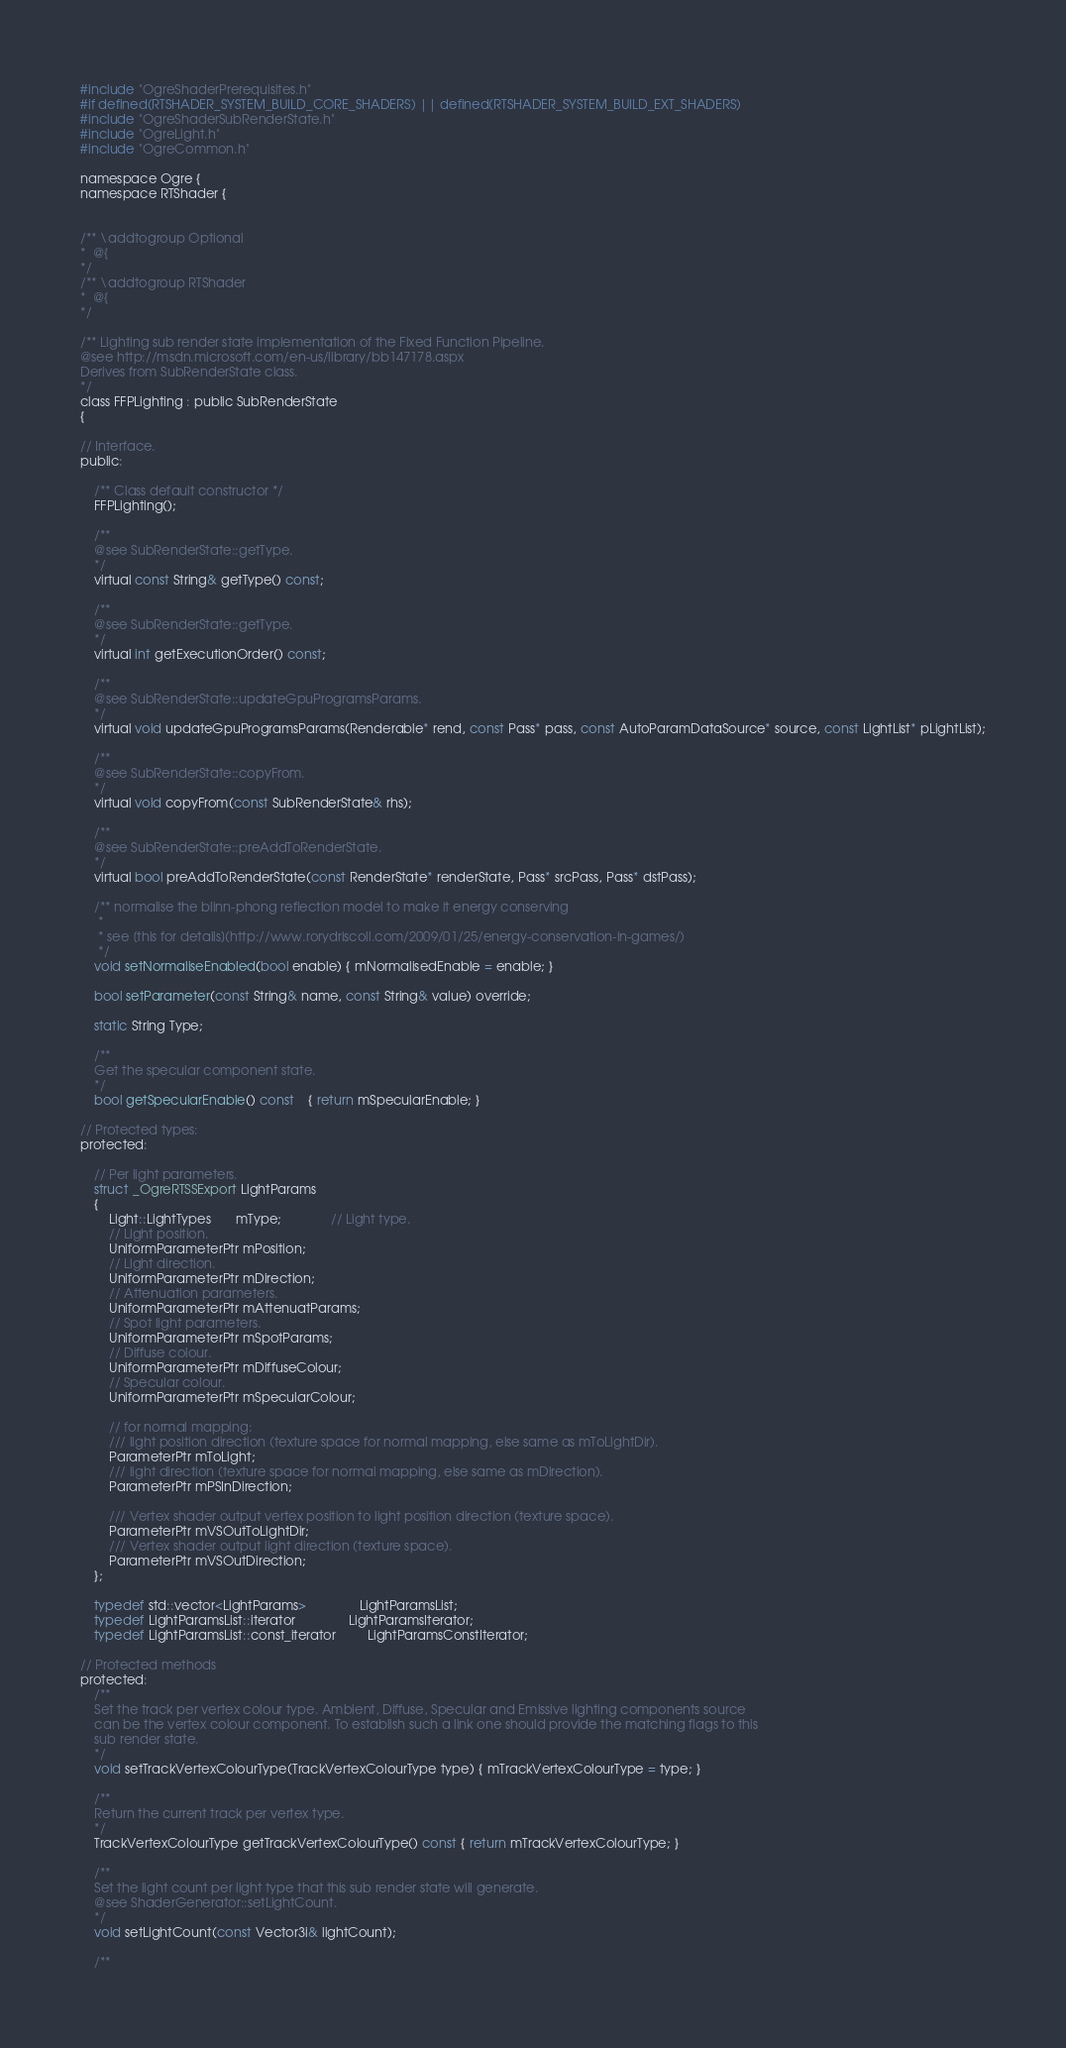<code> <loc_0><loc_0><loc_500><loc_500><_C_>
#include "OgreShaderPrerequisites.h"
#if defined(RTSHADER_SYSTEM_BUILD_CORE_SHADERS) || defined(RTSHADER_SYSTEM_BUILD_EXT_SHADERS)
#include "OgreShaderSubRenderState.h"
#include "OgreLight.h"
#include "OgreCommon.h"

namespace Ogre {
namespace RTShader {


/** \addtogroup Optional
*  @{
*/
/** \addtogroup RTShader
*  @{
*/

/** Lighting sub render state implementation of the Fixed Function Pipeline.
@see http://msdn.microsoft.com/en-us/library/bb147178.aspx
Derives from SubRenderState class.
*/
class FFPLighting : public SubRenderState
{

// Interface.
public:
    
    /** Class default constructor */
    FFPLighting();

    /** 
    @see SubRenderState::getType.
    */
    virtual const String& getType() const;

    /** 
    @see SubRenderState::getType.
    */
    virtual int getExecutionOrder() const;

    /** 
    @see SubRenderState::updateGpuProgramsParams.
    */
    virtual void updateGpuProgramsParams(Renderable* rend, const Pass* pass, const AutoParamDataSource* source, const LightList* pLightList);

    /** 
    @see SubRenderState::copyFrom.
    */
    virtual void copyFrom(const SubRenderState& rhs);

    /** 
    @see SubRenderState::preAddToRenderState.
    */
    virtual bool preAddToRenderState(const RenderState* renderState, Pass* srcPass, Pass* dstPass);

    /** normalise the blinn-phong reflection model to make it energy conserving
     *
     * see [this for details](http://www.rorydriscoll.com/2009/01/25/energy-conservation-in-games/)
     */
    void setNormaliseEnabled(bool enable) { mNormalisedEnable = enable; }

    bool setParameter(const String& name, const String& value) override;

    static String Type;

    /**
    Get the specular component state.
    */
    bool getSpecularEnable() const    { return mSpecularEnable; }

// Protected types:
protected:

    // Per light parameters.
    struct _OgreRTSSExport LightParams
    {
        Light::LightTypes       mType;              // Light type.      
        // Light position.
        UniformParameterPtr mPosition;
        // Light direction.
        UniformParameterPtr mDirection;
        // Attenuation parameters.
        UniformParameterPtr mAttenuatParams;
        // Spot light parameters.
        UniformParameterPtr mSpotParams;
        // Diffuse colour.
        UniformParameterPtr mDiffuseColour;
        // Specular colour.
        UniformParameterPtr mSpecularColour;

        // for normal mapping:
        /// light position direction (texture space for normal mapping, else same as mToLightDir).
        ParameterPtr mToLight;
        /// light direction (texture space for normal mapping, else same as mDirection).
        ParameterPtr mPSInDirection;

        /// Vertex shader output vertex position to light position direction (texture space).
        ParameterPtr mVSOutToLightDir;
        /// Vertex shader output light direction (texture space).
        ParameterPtr mVSOutDirection;
    };

    typedef std::vector<LightParams>               LightParamsList;
    typedef LightParamsList::iterator               LightParamsIterator;
    typedef LightParamsList::const_iterator         LightParamsConstIterator;

// Protected methods
protected:
    /** 
    Set the track per vertex colour type. Ambient, Diffuse, Specular and Emissive lighting components source
    can be the vertex colour component. To establish such a link one should provide the matching flags to this
    sub render state.
    */
    void setTrackVertexColourType(TrackVertexColourType type) { mTrackVertexColourType = type; }

    /** 
    Return the current track per vertex type.
    */
    TrackVertexColourType getTrackVertexColourType() const { return mTrackVertexColourType; }

    /** 
    Set the light count per light type that this sub render state will generate.
    @see ShaderGenerator::setLightCount.
    */
    void setLightCount(const Vector3i& lightCount);

    /** </code> 